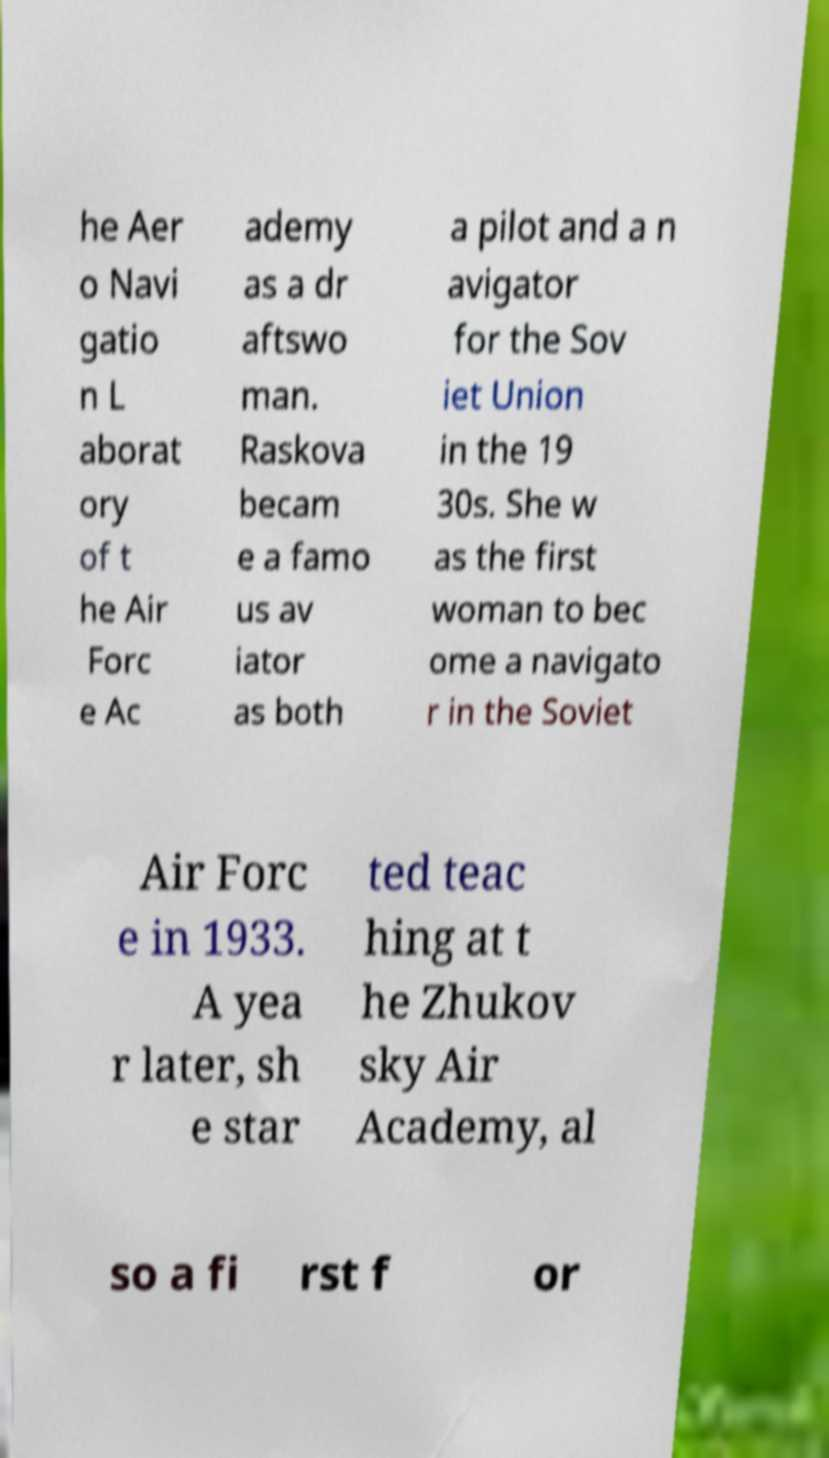For documentation purposes, I need the text within this image transcribed. Could you provide that? he Aer o Navi gatio n L aborat ory of t he Air Forc e Ac ademy as a dr aftswo man. Raskova becam e a famo us av iator as both a pilot and a n avigator for the Sov iet Union in the 19 30s. She w as the first woman to bec ome a navigato r in the Soviet Air Forc e in 1933. A yea r later, sh e star ted teac hing at t he Zhukov sky Air Academy, al so a fi rst f or 